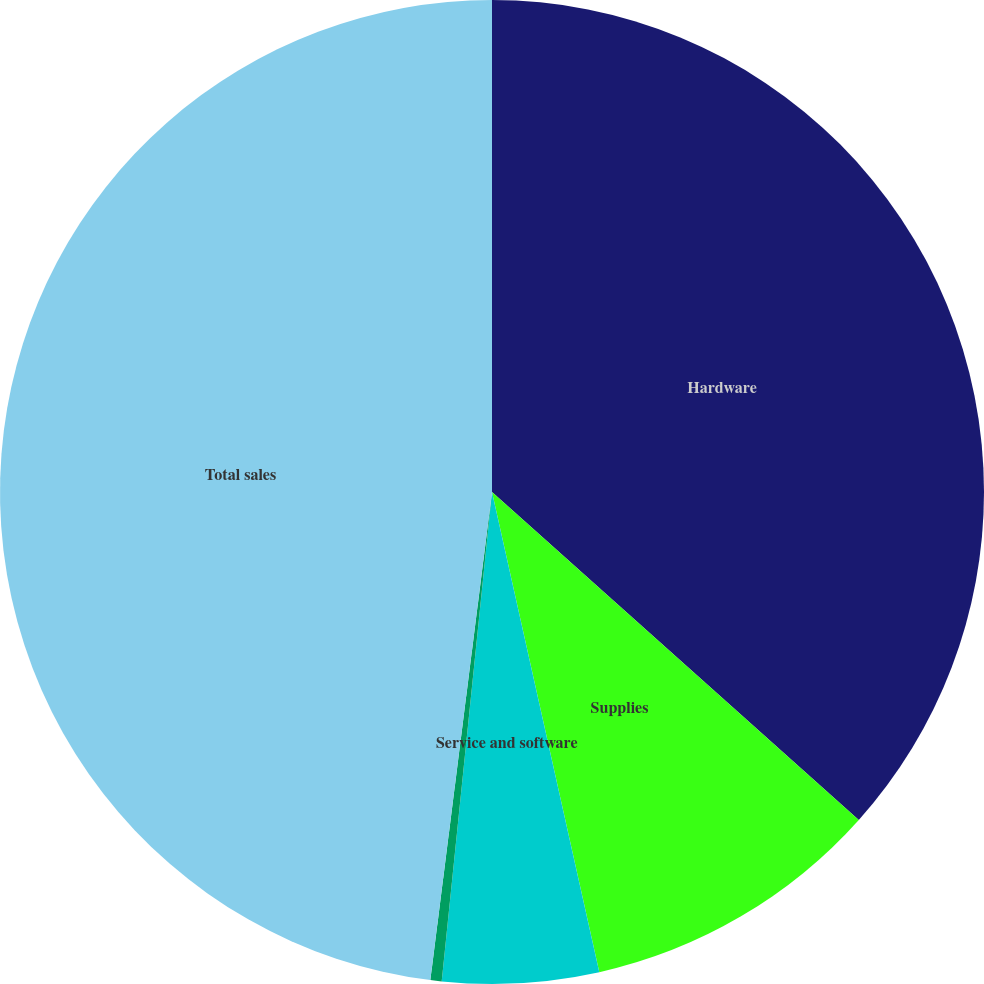<chart> <loc_0><loc_0><loc_500><loc_500><pie_chart><fcel>Hardware<fcel>Supplies<fcel>Service and software<fcel>Shipping and handling<fcel>Total sales<nl><fcel>36.61%<fcel>9.89%<fcel>5.13%<fcel>0.37%<fcel>48.0%<nl></chart> 